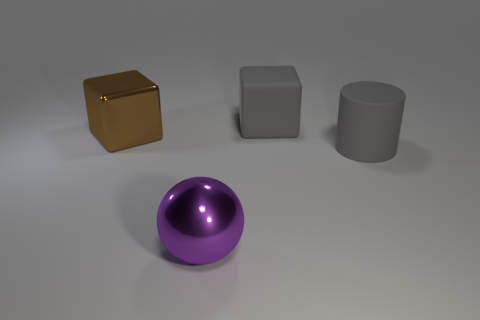How would you describe the lighting in the scene? The lighting in the scene appears to be soft and diffused, with a slight highlight on the upper surfaces of the objects, indicating an overhead light source that enhances the perception of the objects' shapes without creating harsh shadows.  What can you tell me about the texture of the objects? The objects in the image exhibit various textures. The golden box has a reflective surface that produces a sharp mirror-like effect. The gray block appears to have a smooth, matte finish, and the purple sphere seems to have a slightly glossy, reflective texture, while the cylinder has a plain matte surface without any noticeable texture or shine. 